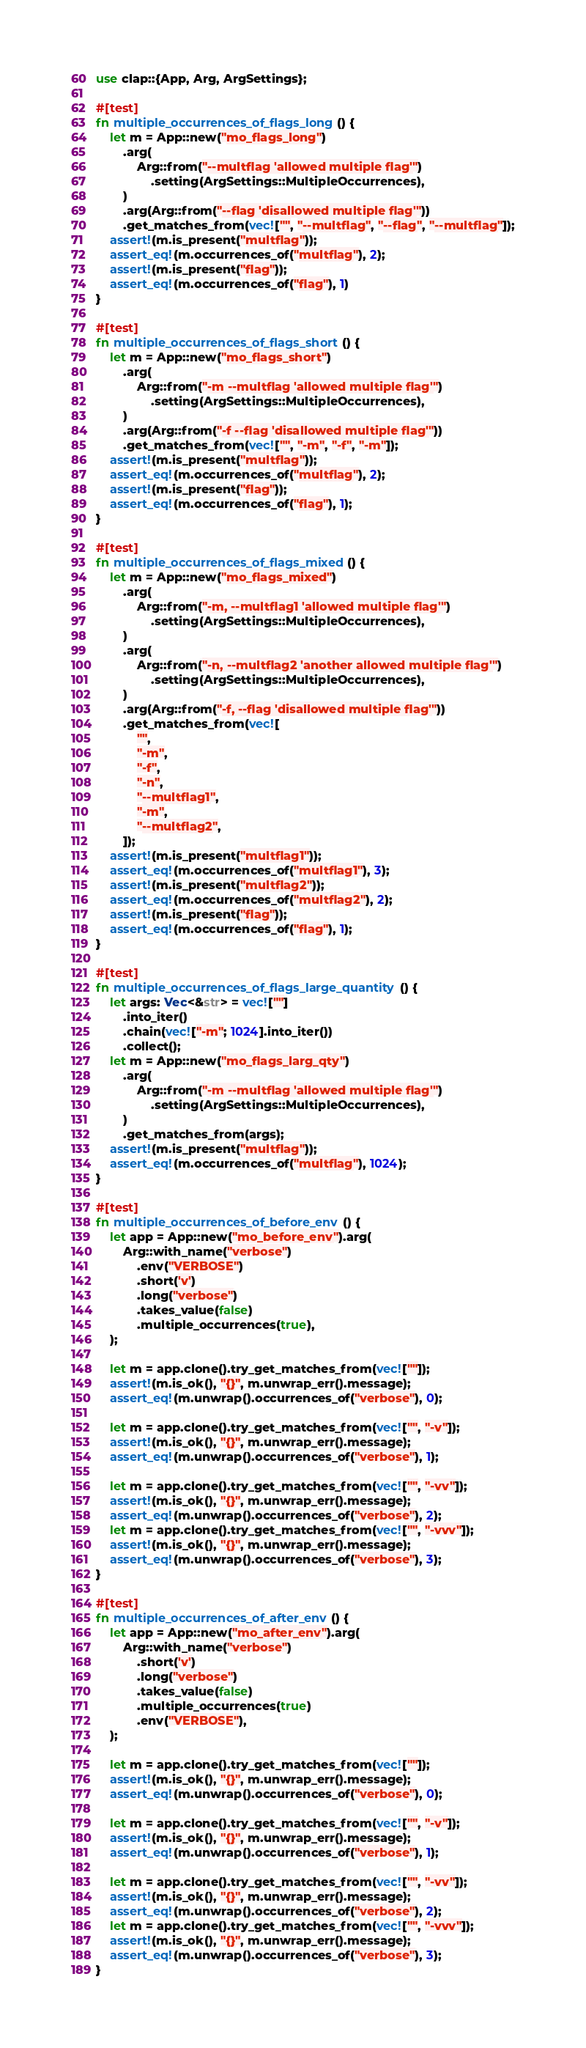<code> <loc_0><loc_0><loc_500><loc_500><_Rust_>use clap::{App, Arg, ArgSettings};

#[test]
fn multiple_occurrences_of_flags_long() {
    let m = App::new("mo_flags_long")
        .arg(
            Arg::from("--multflag 'allowed multiple flag'")
                .setting(ArgSettings::MultipleOccurrences),
        )
        .arg(Arg::from("--flag 'disallowed multiple flag'"))
        .get_matches_from(vec!["", "--multflag", "--flag", "--multflag"]);
    assert!(m.is_present("multflag"));
    assert_eq!(m.occurrences_of("multflag"), 2);
    assert!(m.is_present("flag"));
    assert_eq!(m.occurrences_of("flag"), 1)
}

#[test]
fn multiple_occurrences_of_flags_short() {
    let m = App::new("mo_flags_short")
        .arg(
            Arg::from("-m --multflag 'allowed multiple flag'")
                .setting(ArgSettings::MultipleOccurrences),
        )
        .arg(Arg::from("-f --flag 'disallowed multiple flag'"))
        .get_matches_from(vec!["", "-m", "-f", "-m"]);
    assert!(m.is_present("multflag"));
    assert_eq!(m.occurrences_of("multflag"), 2);
    assert!(m.is_present("flag"));
    assert_eq!(m.occurrences_of("flag"), 1);
}

#[test]
fn multiple_occurrences_of_flags_mixed() {
    let m = App::new("mo_flags_mixed")
        .arg(
            Arg::from("-m, --multflag1 'allowed multiple flag'")
                .setting(ArgSettings::MultipleOccurrences),
        )
        .arg(
            Arg::from("-n, --multflag2 'another allowed multiple flag'")
                .setting(ArgSettings::MultipleOccurrences),
        )
        .arg(Arg::from("-f, --flag 'disallowed multiple flag'"))
        .get_matches_from(vec![
            "",
            "-m",
            "-f",
            "-n",
            "--multflag1",
            "-m",
            "--multflag2",
        ]);
    assert!(m.is_present("multflag1"));
    assert_eq!(m.occurrences_of("multflag1"), 3);
    assert!(m.is_present("multflag2"));
    assert_eq!(m.occurrences_of("multflag2"), 2);
    assert!(m.is_present("flag"));
    assert_eq!(m.occurrences_of("flag"), 1);
}

#[test]
fn multiple_occurrences_of_flags_large_quantity() {
    let args: Vec<&str> = vec![""]
        .into_iter()
        .chain(vec!["-m"; 1024].into_iter())
        .collect();
    let m = App::new("mo_flags_larg_qty")
        .arg(
            Arg::from("-m --multflag 'allowed multiple flag'")
                .setting(ArgSettings::MultipleOccurrences),
        )
        .get_matches_from(args);
    assert!(m.is_present("multflag"));
    assert_eq!(m.occurrences_of("multflag"), 1024);
}

#[test]
fn multiple_occurrences_of_before_env() {
    let app = App::new("mo_before_env").arg(
        Arg::with_name("verbose")
            .env("VERBOSE")
            .short('v')
            .long("verbose")
            .takes_value(false)
            .multiple_occurrences(true),
    );

    let m = app.clone().try_get_matches_from(vec![""]);
    assert!(m.is_ok(), "{}", m.unwrap_err().message);
    assert_eq!(m.unwrap().occurrences_of("verbose"), 0);

    let m = app.clone().try_get_matches_from(vec!["", "-v"]);
    assert!(m.is_ok(), "{}", m.unwrap_err().message);
    assert_eq!(m.unwrap().occurrences_of("verbose"), 1);

    let m = app.clone().try_get_matches_from(vec!["", "-vv"]);
    assert!(m.is_ok(), "{}", m.unwrap_err().message);
    assert_eq!(m.unwrap().occurrences_of("verbose"), 2);
    let m = app.clone().try_get_matches_from(vec!["", "-vvv"]);
    assert!(m.is_ok(), "{}", m.unwrap_err().message);
    assert_eq!(m.unwrap().occurrences_of("verbose"), 3);
}

#[test]
fn multiple_occurrences_of_after_env() {
    let app = App::new("mo_after_env").arg(
        Arg::with_name("verbose")
            .short('v')
            .long("verbose")
            .takes_value(false)
            .multiple_occurrences(true)
            .env("VERBOSE"),
    );

    let m = app.clone().try_get_matches_from(vec![""]);
    assert!(m.is_ok(), "{}", m.unwrap_err().message);
    assert_eq!(m.unwrap().occurrences_of("verbose"), 0);

    let m = app.clone().try_get_matches_from(vec!["", "-v"]);
    assert!(m.is_ok(), "{}", m.unwrap_err().message);
    assert_eq!(m.unwrap().occurrences_of("verbose"), 1);

    let m = app.clone().try_get_matches_from(vec!["", "-vv"]);
    assert!(m.is_ok(), "{}", m.unwrap_err().message);
    assert_eq!(m.unwrap().occurrences_of("verbose"), 2);
    let m = app.clone().try_get_matches_from(vec!["", "-vvv"]);
    assert!(m.is_ok(), "{}", m.unwrap_err().message);
    assert_eq!(m.unwrap().occurrences_of("verbose"), 3);
}
</code> 